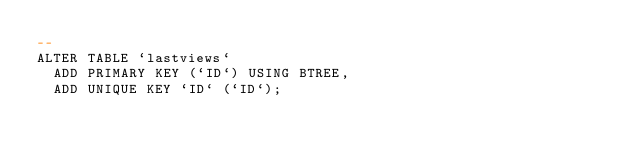Convert code to text. <code><loc_0><loc_0><loc_500><loc_500><_SQL_>--
ALTER TABLE `lastviews`
  ADD PRIMARY KEY (`ID`) USING BTREE,
  ADD UNIQUE KEY `ID` (`ID`);</code> 